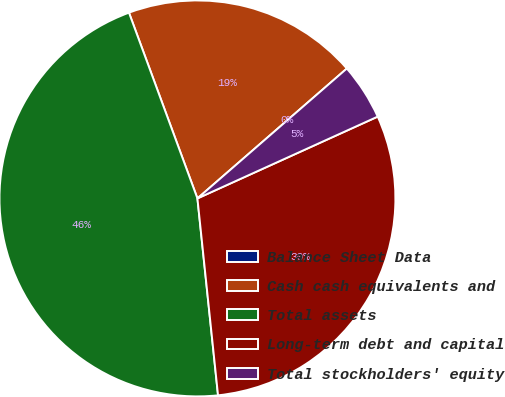<chart> <loc_0><loc_0><loc_500><loc_500><pie_chart><fcel>Balance Sheet Data<fcel>Cash cash equivalents and<fcel>Total assets<fcel>Long-term debt and capital<fcel>Total stockholders' equity<nl><fcel>0.0%<fcel>19.23%<fcel>46.04%<fcel>30.12%<fcel>4.61%<nl></chart> 